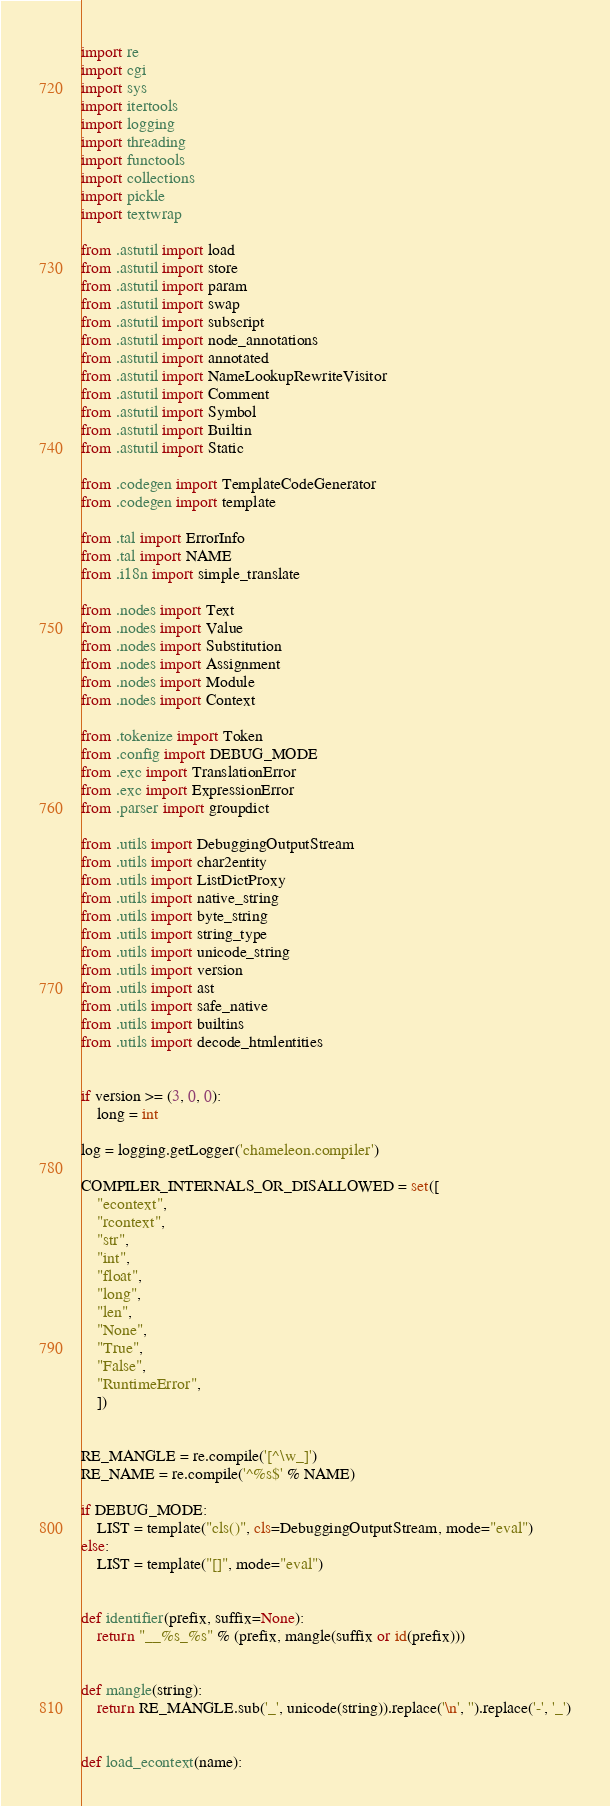Convert code to text. <code><loc_0><loc_0><loc_500><loc_500><_Python_>import re
import cgi
import sys
import itertools
import logging
import threading
import functools
import collections
import pickle
import textwrap

from .astutil import load
from .astutil import store
from .astutil import param
from .astutil import swap
from .astutil import subscript
from .astutil import node_annotations
from .astutil import annotated
from .astutil import NameLookupRewriteVisitor
from .astutil import Comment
from .astutil import Symbol
from .astutil import Builtin
from .astutil import Static

from .codegen import TemplateCodeGenerator
from .codegen import template

from .tal import ErrorInfo
from .tal import NAME
from .i18n import simple_translate

from .nodes import Text
from .nodes import Value
from .nodes import Substitution
from .nodes import Assignment
from .nodes import Module
from .nodes import Context

from .tokenize import Token
from .config import DEBUG_MODE
from .exc import TranslationError
from .exc import ExpressionError
from .parser import groupdict

from .utils import DebuggingOutputStream
from .utils import char2entity
from .utils import ListDictProxy
from .utils import native_string
from .utils import byte_string
from .utils import string_type
from .utils import unicode_string
from .utils import version
from .utils import ast
from .utils import safe_native
from .utils import builtins
from .utils import decode_htmlentities


if version >= (3, 0, 0):
    long = int

log = logging.getLogger('chameleon.compiler')

COMPILER_INTERNALS_OR_DISALLOWED = set([
    "econtext",
    "rcontext",
    "str",
    "int",
    "float",
    "long",
    "len",
    "None",
    "True",
    "False",
    "RuntimeError",
    ])


RE_MANGLE = re.compile('[^\w_]')
RE_NAME = re.compile('^%s$' % NAME)

if DEBUG_MODE:
    LIST = template("cls()", cls=DebuggingOutputStream, mode="eval")
else:
    LIST = template("[]", mode="eval")


def identifier(prefix, suffix=None):
    return "__%s_%s" % (prefix, mangle(suffix or id(prefix)))


def mangle(string):
    return RE_MANGLE.sub('_', unicode(string)).replace('\n', '').replace('-', '_')


def load_econtext(name):</code> 